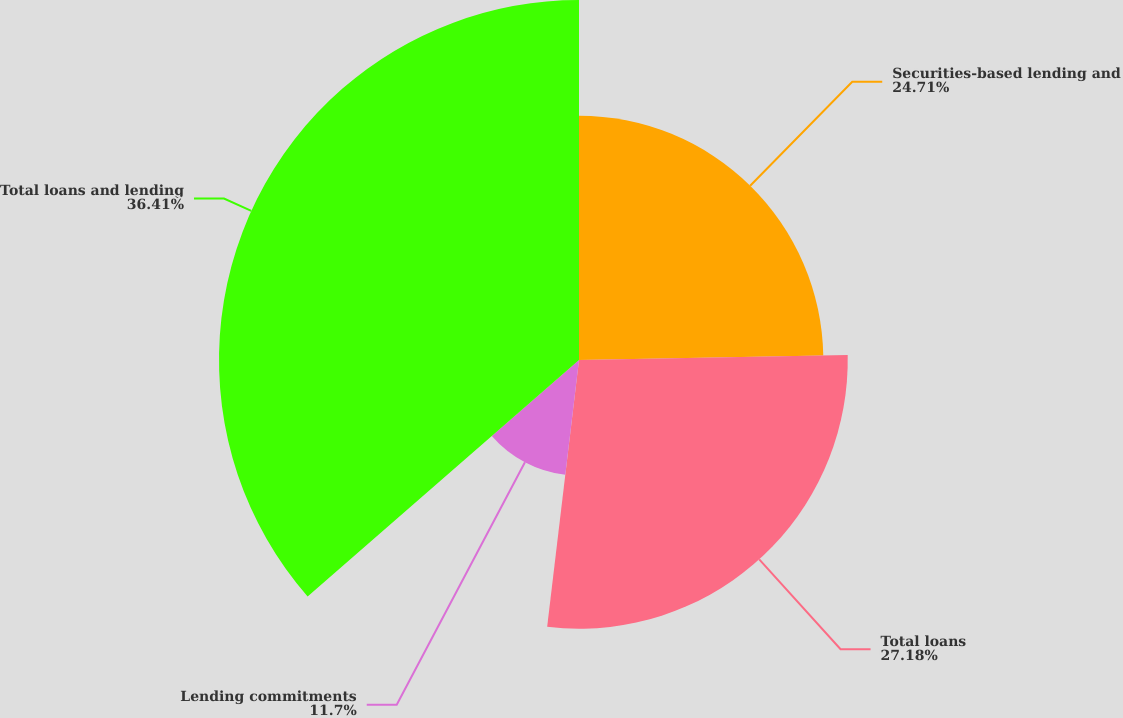<chart> <loc_0><loc_0><loc_500><loc_500><pie_chart><fcel>Securities-based lending and<fcel>Total loans<fcel>Lending commitments<fcel>Total loans and lending<nl><fcel>24.71%<fcel>27.18%<fcel>11.7%<fcel>36.41%<nl></chart> 